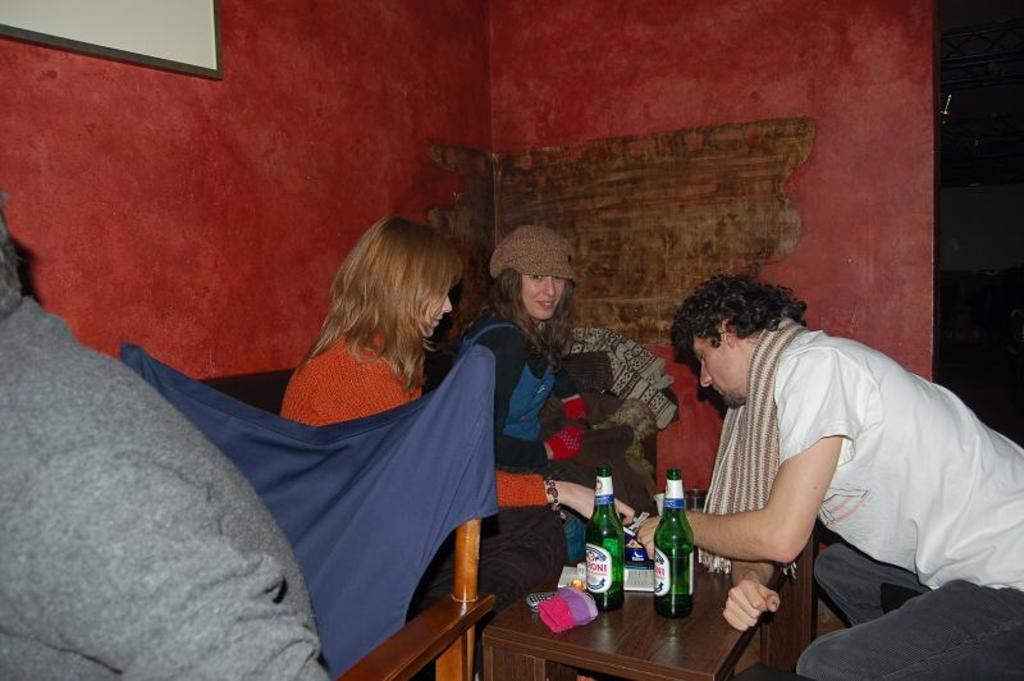Describe this image in one or two sentences. In this image we can see three persons are sitting around the table. There are bottles and gloves on the table. In the background there is a photo frame attached to the red color wall. 